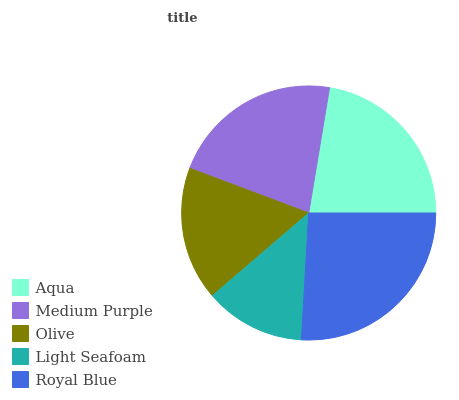Is Light Seafoam the minimum?
Answer yes or no. Yes. Is Royal Blue the maximum?
Answer yes or no. Yes. Is Medium Purple the minimum?
Answer yes or no. No. Is Medium Purple the maximum?
Answer yes or no. No. Is Aqua greater than Medium Purple?
Answer yes or no. Yes. Is Medium Purple less than Aqua?
Answer yes or no. Yes. Is Medium Purple greater than Aqua?
Answer yes or no. No. Is Aqua less than Medium Purple?
Answer yes or no. No. Is Medium Purple the high median?
Answer yes or no. Yes. Is Medium Purple the low median?
Answer yes or no. Yes. Is Royal Blue the high median?
Answer yes or no. No. Is Light Seafoam the low median?
Answer yes or no. No. 